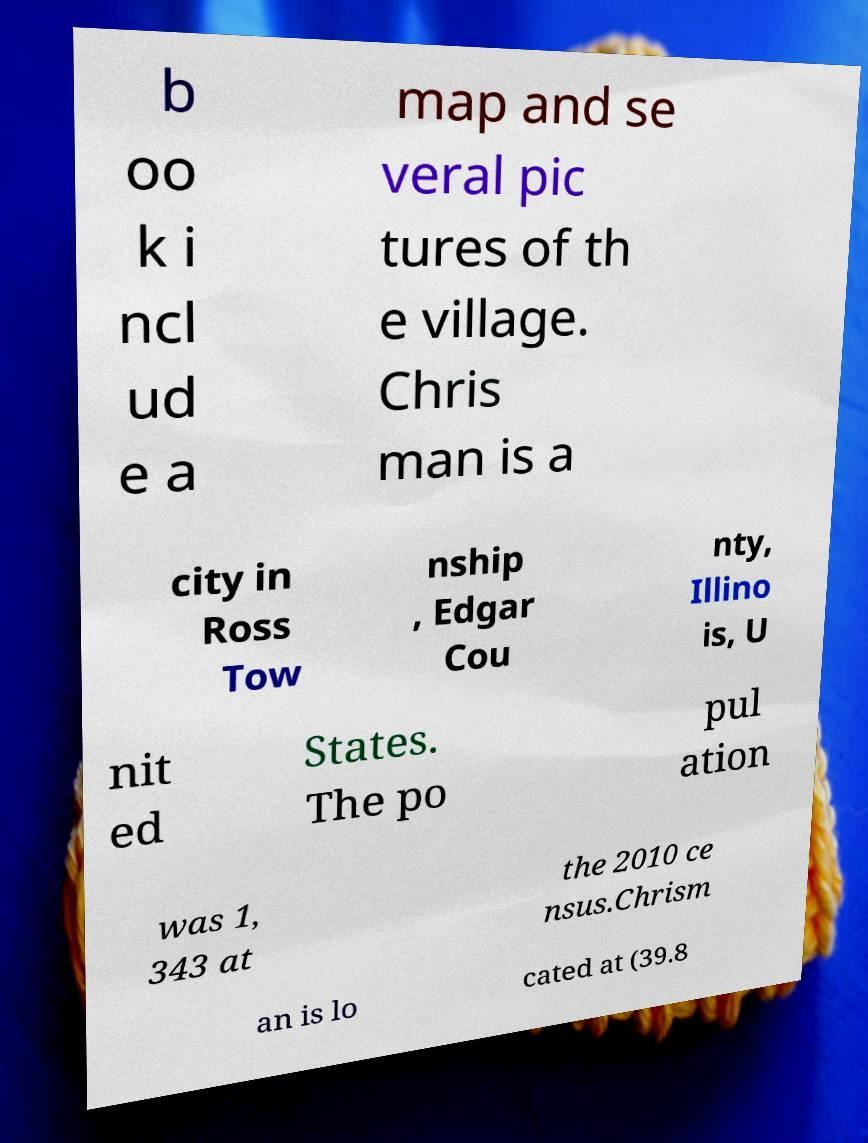Could you assist in decoding the text presented in this image and type it out clearly? b oo k i ncl ud e a map and se veral pic tures of th e village. Chris man is a city in Ross Tow nship , Edgar Cou nty, Illino is, U nit ed States. The po pul ation was 1, 343 at the 2010 ce nsus.Chrism an is lo cated at (39.8 